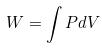Convert formula to latex. <formula><loc_0><loc_0><loc_500><loc_500>W = \int P d V</formula> 